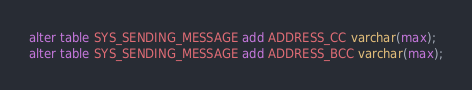Convert code to text. <code><loc_0><loc_0><loc_500><loc_500><_SQL_>alter table SYS_SENDING_MESSAGE add ADDRESS_CC varchar(max);
alter table SYS_SENDING_MESSAGE add ADDRESS_BCC varchar(max);</code> 